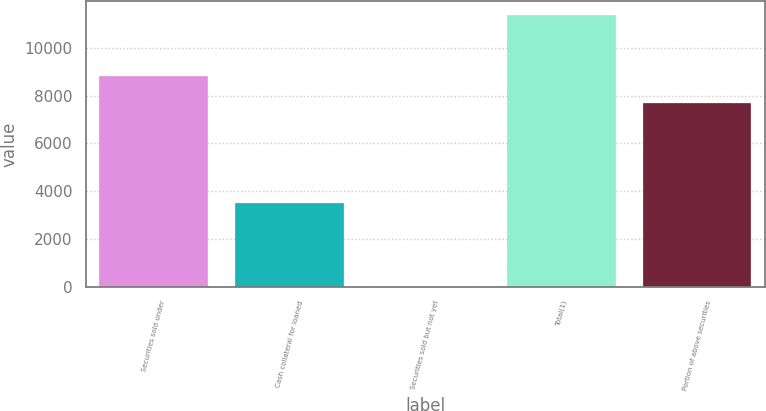Convert chart. <chart><loc_0><loc_0><loc_500><loc_500><bar_chart><fcel>Securities sold under<fcel>Cash collateral for loaned<fcel>Securities sold but not yet<fcel>Total(1)<fcel>Portion of above securities<nl><fcel>8828.8<fcel>3496<fcel>2<fcel>11380<fcel>7691<nl></chart> 